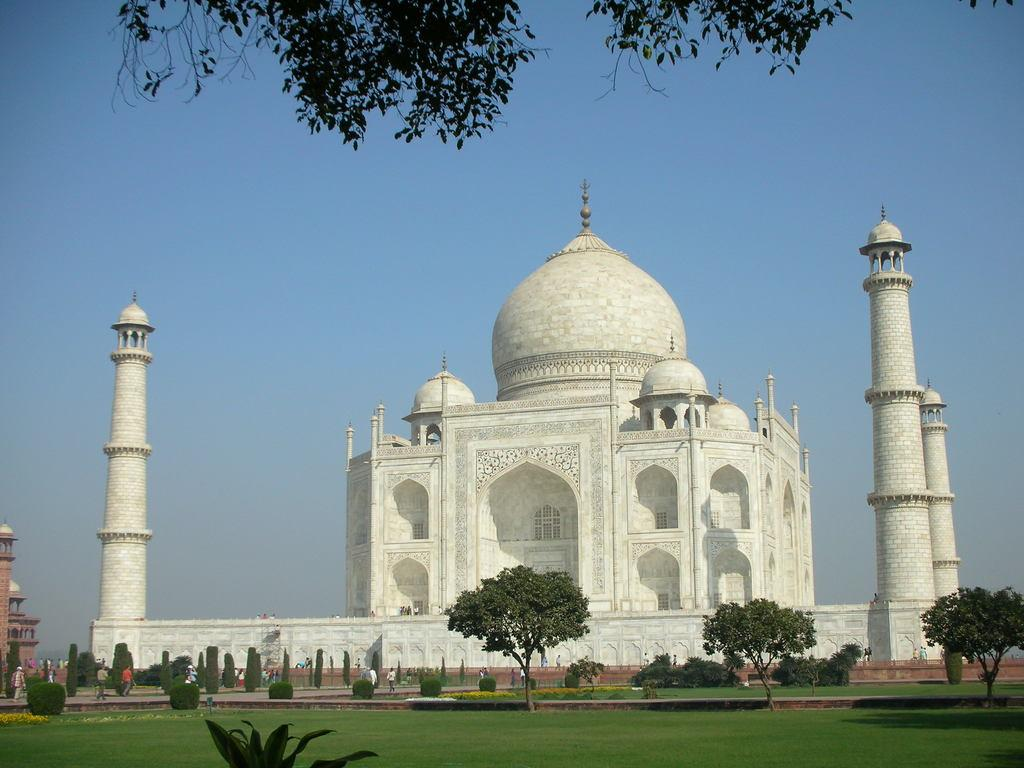What famous landmark is shown in the image? The image depicts the Taj Mahal. What type of vegetation can be seen in the image? There is grass, plants, and trees in the image. Are there any living beings in the image? Yes, there are people in the image. What can be seen in the background of the image? The sky is visible in the background of the image. What type of tax is being discussed by the people in the image? There is no indication in the image that the people are discussing any type of tax. What color is the paint used on the linen in the image? There is no paint or linen present in the image. 